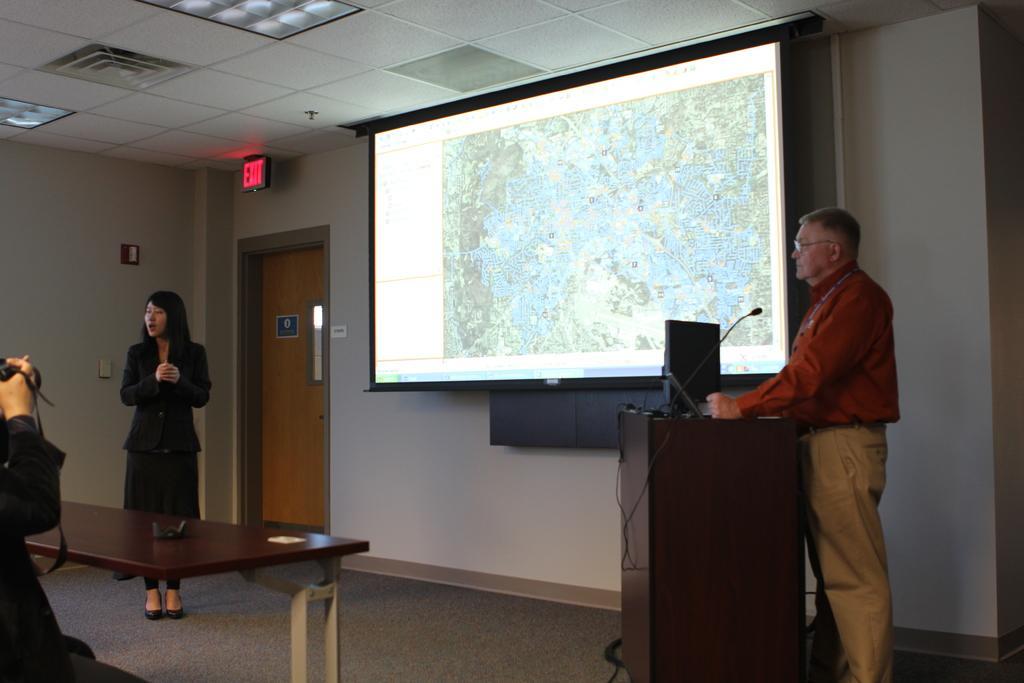Please provide a concise description of this image. This picture is inside view of a room. In the center of the image we can see a projector screen is there. On the right side of the image we can see a table. On the table screen, mic, wires are there. A person is standing beside the table. On the left side of the image we can see a lady is standing. There is a bench, on the bench an object is there. A person is holding an object. In the background of the image we can see wall, lights, sign board, door are present. At the bottom of the image floor is there. At the top of the image roof is present. 